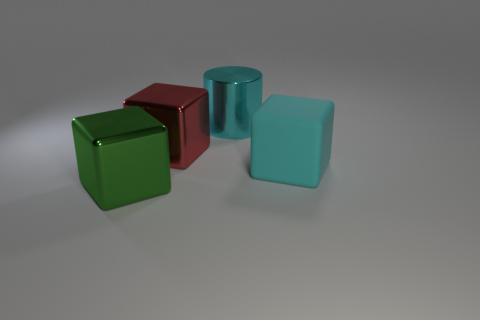How do the textures of the objects compare? All objects in the image have a smooth and shiny texture. This reflective quality gives them a sense of uniform material, despite their different shapes and colors. 